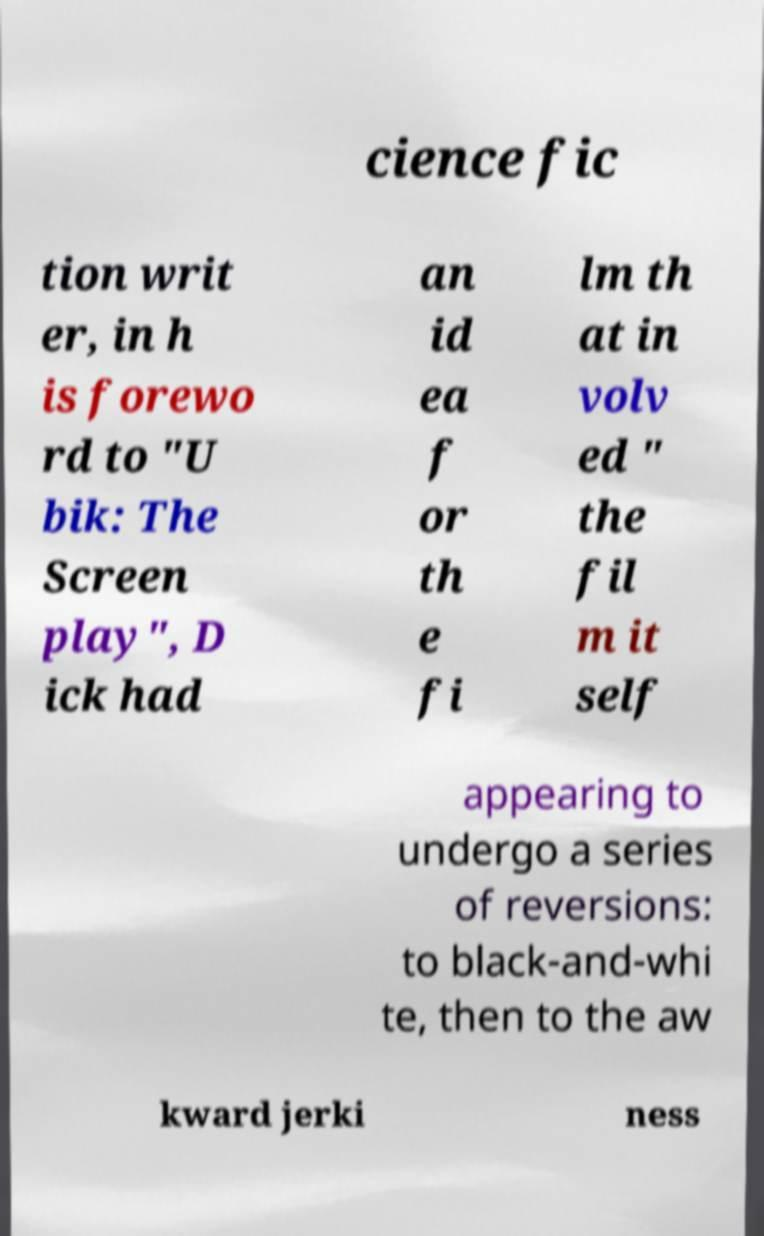Could you assist in decoding the text presented in this image and type it out clearly? cience fic tion writ er, in h is forewo rd to "U bik: The Screen play", D ick had an id ea f or th e fi lm th at in volv ed " the fil m it self appearing to undergo a series of reversions: to black-and-whi te, then to the aw kward jerki ness 